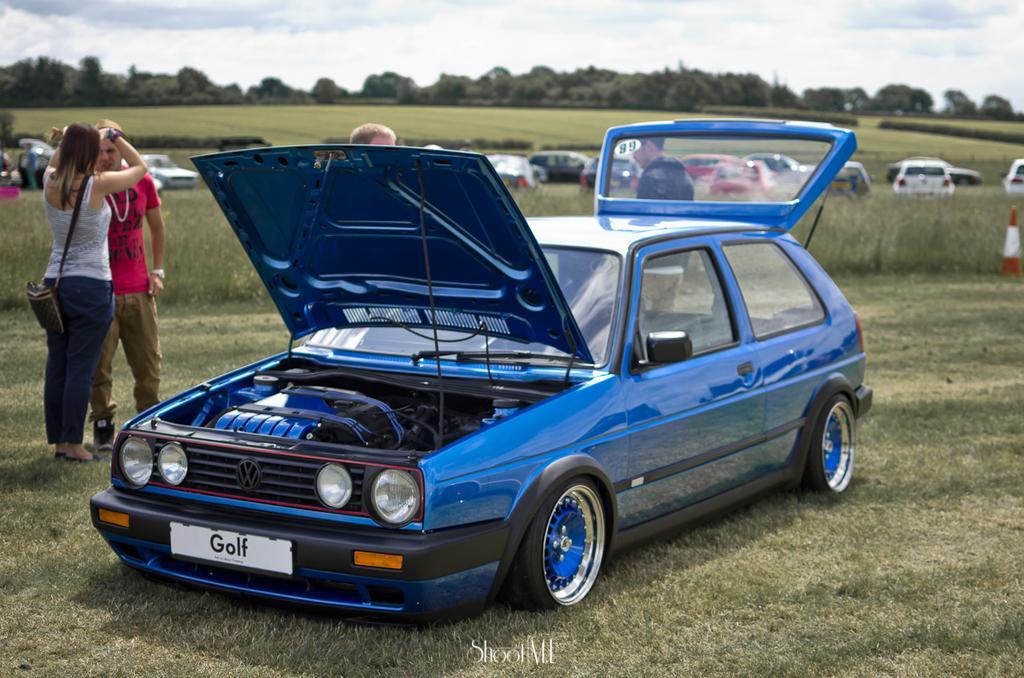Can you describe this image briefly? This is the picture of a grass field. In the foreground there is a blue color car and there are group of people standing behind the car. At the back there are vehicles and trees. At the top there is sky and there are clouds. At the bottom there is grass and there is a text. 